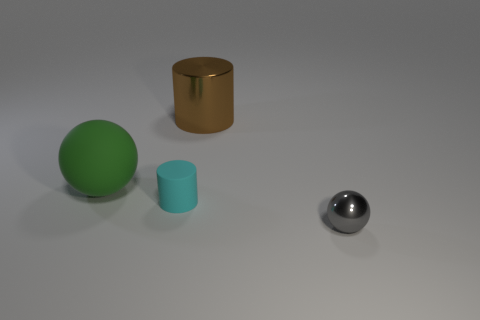What size is the cyan rubber cylinder?
Offer a very short reply. Small. There is a ball on the left side of the tiny gray sphere; what number of gray metallic things are on the left side of it?
Make the answer very short. 0. Is there any other thing that is the same shape as the large green object?
Give a very brief answer. Yes. Is the number of tiny yellow metallic cubes less than the number of cyan things?
Your response must be concise. Yes. What is the shape of the thing on the left side of the small thing behind the small shiny ball?
Your answer should be very brief. Sphere. There is a object to the right of the brown metal thing on the left side of the sphere that is in front of the rubber cylinder; what shape is it?
Offer a terse response. Sphere. How many objects are things that are in front of the green matte ball or things that are behind the green sphere?
Give a very brief answer. 3. Does the matte cylinder have the same size as the sphere that is on the right side of the big matte ball?
Your answer should be very brief. Yes. Is the material of the sphere on the right side of the large matte sphere the same as the cylinder that is to the left of the large brown metal cylinder?
Your answer should be compact. No. Are there an equal number of gray shiny things behind the big cylinder and large cylinders on the right side of the tiny cyan rubber cylinder?
Offer a terse response. No. 